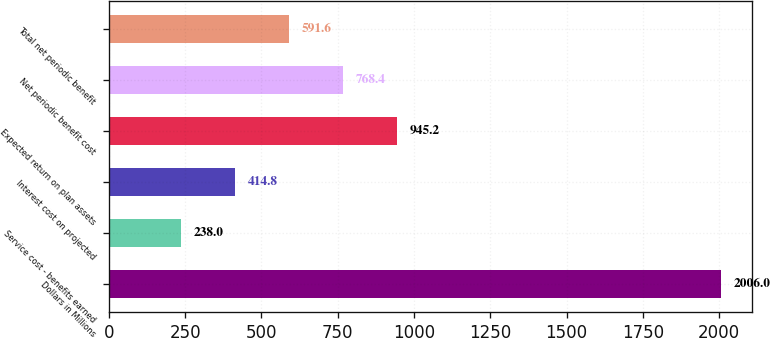Convert chart. <chart><loc_0><loc_0><loc_500><loc_500><bar_chart><fcel>Dollars in Millions<fcel>Service cost - benefits earned<fcel>Interest cost on projected<fcel>Expected return on plan assets<fcel>Net periodic benefit cost<fcel>Total net periodic benefit<nl><fcel>2006<fcel>238<fcel>414.8<fcel>945.2<fcel>768.4<fcel>591.6<nl></chart> 